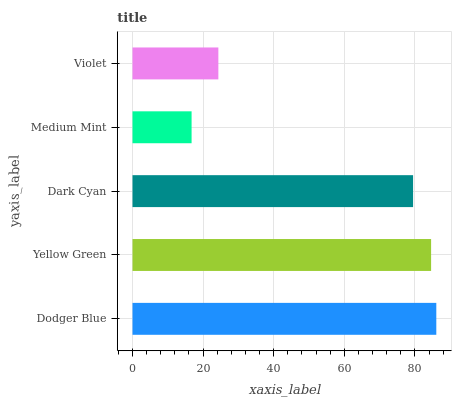Is Medium Mint the minimum?
Answer yes or no. Yes. Is Dodger Blue the maximum?
Answer yes or no. Yes. Is Yellow Green the minimum?
Answer yes or no. No. Is Yellow Green the maximum?
Answer yes or no. No. Is Dodger Blue greater than Yellow Green?
Answer yes or no. Yes. Is Yellow Green less than Dodger Blue?
Answer yes or no. Yes. Is Yellow Green greater than Dodger Blue?
Answer yes or no. No. Is Dodger Blue less than Yellow Green?
Answer yes or no. No. Is Dark Cyan the high median?
Answer yes or no. Yes. Is Dark Cyan the low median?
Answer yes or no. Yes. Is Yellow Green the high median?
Answer yes or no. No. Is Yellow Green the low median?
Answer yes or no. No. 